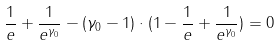Convert formula to latex. <formula><loc_0><loc_0><loc_500><loc_500>\frac { 1 } { e } + \frac { 1 } { e ^ { \gamma _ { 0 } } } - ( \gamma _ { 0 } - 1 ) \cdot ( 1 - \frac { 1 } { e } + \frac { 1 } { e ^ { \gamma _ { 0 } } } ) = 0</formula> 